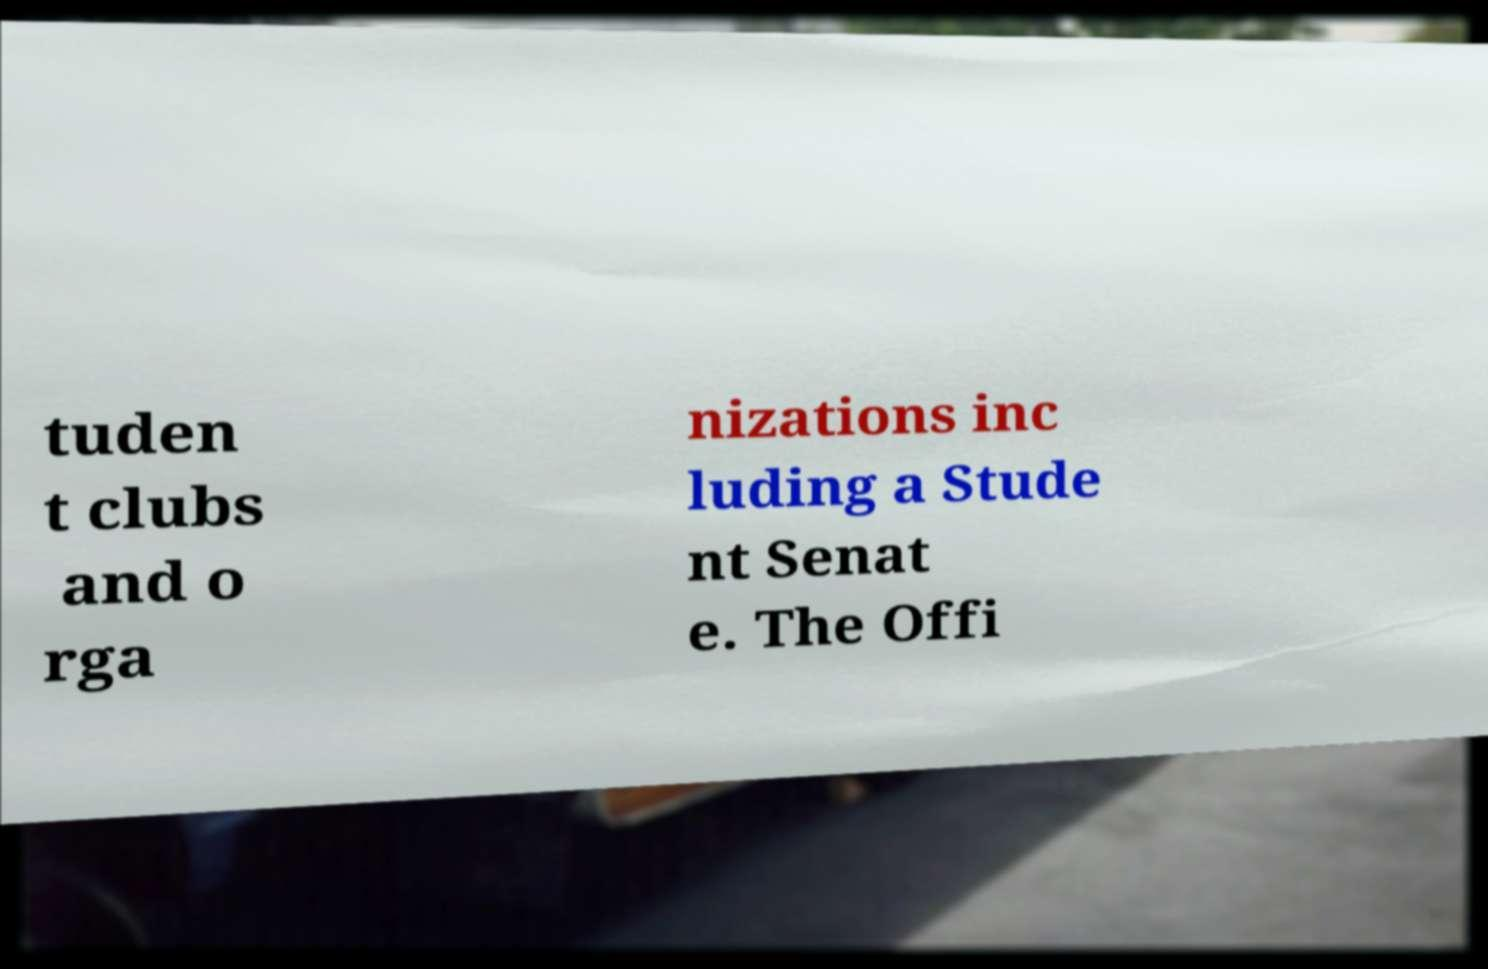I need the written content from this picture converted into text. Can you do that? tuden t clubs and o rga nizations inc luding a Stude nt Senat e. The Offi 